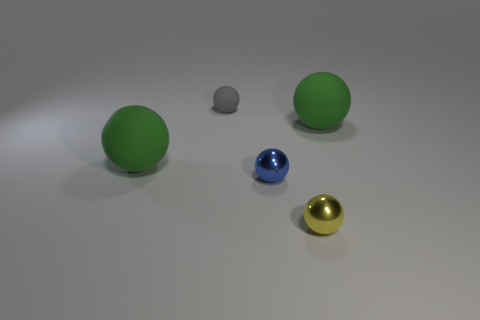Subtract all small yellow spheres. How many spheres are left? 4 Add 1 small brown metallic cylinders. How many objects exist? 6 Subtract all gray balls. How many balls are left? 4 Add 5 big green spheres. How many big green spheres are left? 7 Add 1 big brown shiny objects. How many big brown shiny objects exist? 1 Subtract 0 green cylinders. How many objects are left? 5 Subtract 1 balls. How many balls are left? 4 Subtract all gray balls. Subtract all brown cylinders. How many balls are left? 4 Subtract all red blocks. How many blue balls are left? 1 Subtract all small blue rubber things. Subtract all metallic objects. How many objects are left? 3 